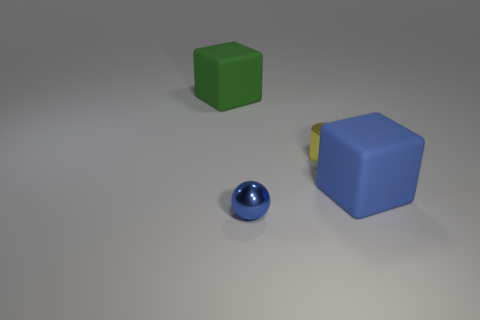Add 4 tiny blue rubber balls. How many objects exist? 8 Subtract all purple cylinders. Subtract all red blocks. How many cylinders are left? 1 Subtract all cyan spheres. How many gray blocks are left? 0 Subtract all cyan metal cylinders. Subtract all big matte cubes. How many objects are left? 2 Add 2 blue rubber blocks. How many blue rubber blocks are left? 3 Add 4 tiny objects. How many tiny objects exist? 6 Subtract 0 blue cylinders. How many objects are left? 4 Subtract 1 cylinders. How many cylinders are left? 0 